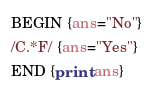<code> <loc_0><loc_0><loc_500><loc_500><_Awk_>BEGIN {ans="No"}
/C.*F/ {ans="Yes"}
END {print ans}</code> 